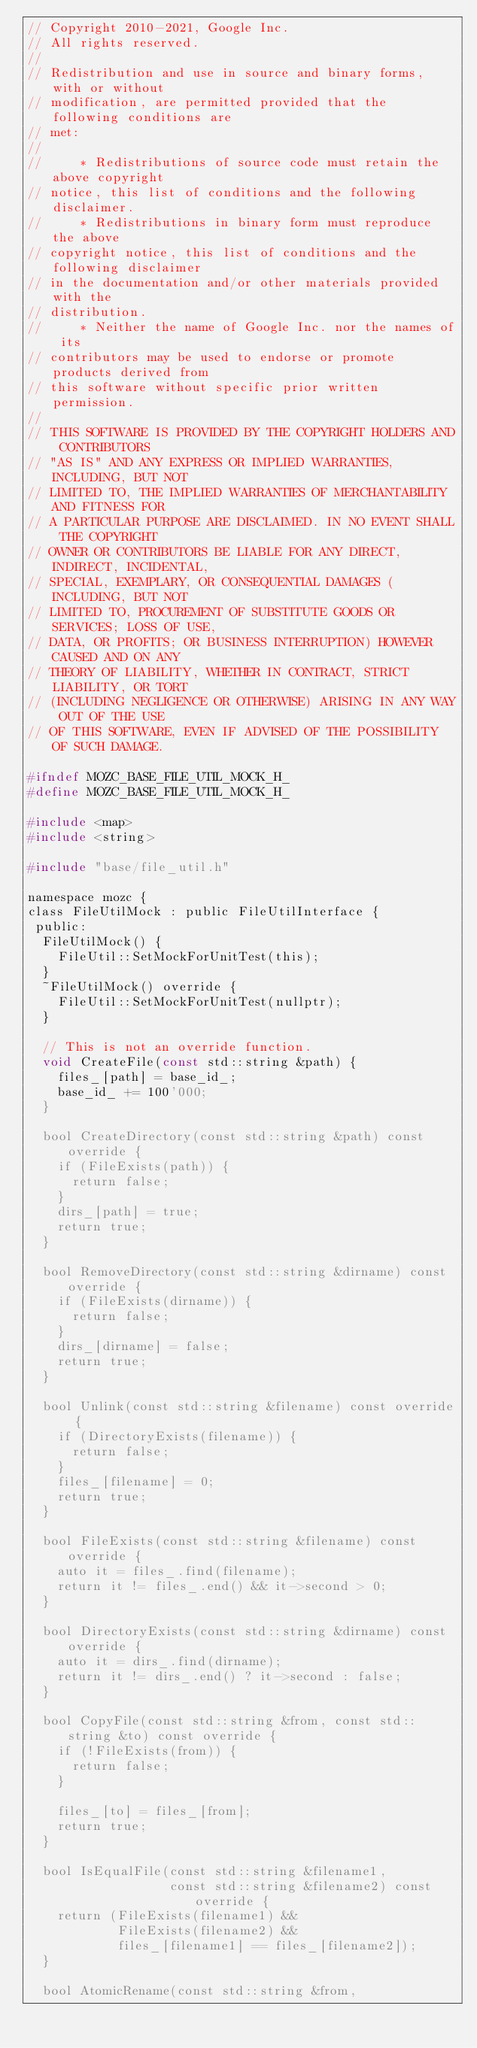<code> <loc_0><loc_0><loc_500><loc_500><_C_>// Copyright 2010-2021, Google Inc.
// All rights reserved.
//
// Redistribution and use in source and binary forms, with or without
// modification, are permitted provided that the following conditions are
// met:
//
//     * Redistributions of source code must retain the above copyright
// notice, this list of conditions and the following disclaimer.
//     * Redistributions in binary form must reproduce the above
// copyright notice, this list of conditions and the following disclaimer
// in the documentation and/or other materials provided with the
// distribution.
//     * Neither the name of Google Inc. nor the names of its
// contributors may be used to endorse or promote products derived from
// this software without specific prior written permission.
//
// THIS SOFTWARE IS PROVIDED BY THE COPYRIGHT HOLDERS AND CONTRIBUTORS
// "AS IS" AND ANY EXPRESS OR IMPLIED WARRANTIES, INCLUDING, BUT NOT
// LIMITED TO, THE IMPLIED WARRANTIES OF MERCHANTABILITY AND FITNESS FOR
// A PARTICULAR PURPOSE ARE DISCLAIMED. IN NO EVENT SHALL THE COPYRIGHT
// OWNER OR CONTRIBUTORS BE LIABLE FOR ANY DIRECT, INDIRECT, INCIDENTAL,
// SPECIAL, EXEMPLARY, OR CONSEQUENTIAL DAMAGES (INCLUDING, BUT NOT
// LIMITED TO, PROCUREMENT OF SUBSTITUTE GOODS OR SERVICES; LOSS OF USE,
// DATA, OR PROFITS; OR BUSINESS INTERRUPTION) HOWEVER CAUSED AND ON ANY
// THEORY OF LIABILITY, WHETHER IN CONTRACT, STRICT LIABILITY, OR TORT
// (INCLUDING NEGLIGENCE OR OTHERWISE) ARISING IN ANY WAY OUT OF THE USE
// OF THIS SOFTWARE, EVEN IF ADVISED OF THE POSSIBILITY OF SUCH DAMAGE.

#ifndef MOZC_BASE_FILE_UTIL_MOCK_H_
#define MOZC_BASE_FILE_UTIL_MOCK_H_

#include <map>
#include <string>

#include "base/file_util.h"

namespace mozc {
class FileUtilMock : public FileUtilInterface {
 public:
  FileUtilMock() {
    FileUtil::SetMockForUnitTest(this);
  }
  ~FileUtilMock() override {
    FileUtil::SetMockForUnitTest(nullptr);
  }

  // This is not an override function.
  void CreateFile(const std::string &path) {
    files_[path] = base_id_;
    base_id_ += 100'000;
  }

  bool CreateDirectory(const std::string &path) const override {
    if (FileExists(path)) {
      return false;
    }
    dirs_[path] = true;
    return true;
  }

  bool RemoveDirectory(const std::string &dirname) const override {
    if (FileExists(dirname)) {
      return false;
    }
    dirs_[dirname] = false;
    return true;
  }

  bool Unlink(const std::string &filename) const override {
    if (DirectoryExists(filename)) {
      return false;
    }
    files_[filename] = 0;
    return true;
  }

  bool FileExists(const std::string &filename) const override {
    auto it = files_.find(filename);
    return it != files_.end() && it->second > 0;
  }

  bool DirectoryExists(const std::string &dirname) const override {
    auto it = dirs_.find(dirname);
    return it != dirs_.end() ? it->second : false;
  }

  bool CopyFile(const std::string &from, const std::string &to) const override {
    if (!FileExists(from)) {
      return false;
    }

    files_[to] = files_[from];
    return true;
  }

  bool IsEqualFile(const std::string &filename1,
                   const std::string &filename2) const override {
    return (FileExists(filename1) &&
            FileExists(filename2) &&
            files_[filename1] == files_[filename2]);
  }

  bool AtomicRename(const std::string &from,</code> 